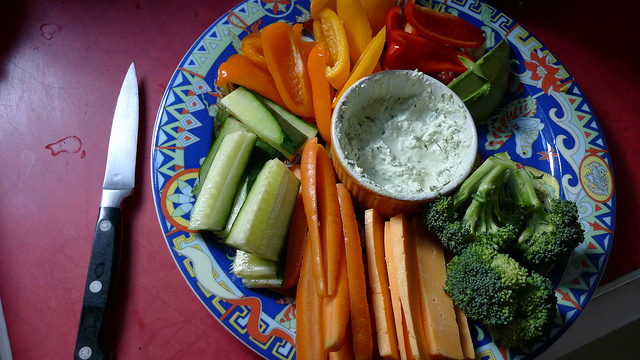Can you suggest a type of event where this vegetable platter would be ideal? This colorful vegetable platter would be a hit at events like a casual get-together, a picnic, a potluck, or even as a healthy snack option at a birthday party or game night. 